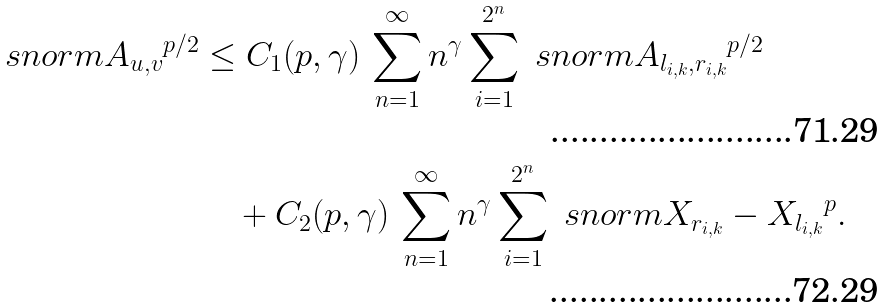<formula> <loc_0><loc_0><loc_500><loc_500>\ s n o r m { A _ { u , v } } ^ { p / 2 } & \leq C _ { 1 } ( p , \gamma ) \, \sum _ { n = 1 } ^ { \infty } n ^ { \gamma } \sum _ { i = 1 } ^ { 2 ^ { n } } \ s n o r m { A _ { l _ { i , k } , r _ { i , k } } } ^ { p / 2 } \\ & \quad + C _ { 2 } ( p , \gamma ) \, \sum _ { n = 1 } ^ { \infty } n ^ { \gamma } \sum _ { i = 1 } ^ { 2 ^ { n } } \ s n o r m { X _ { r _ { i , k } } - X _ { l _ { i , k } } } ^ { p } .</formula> 